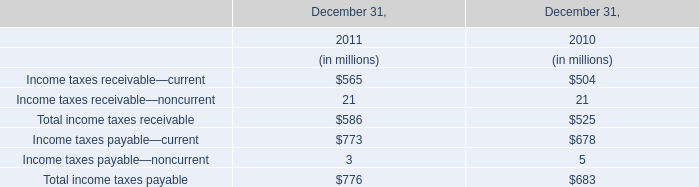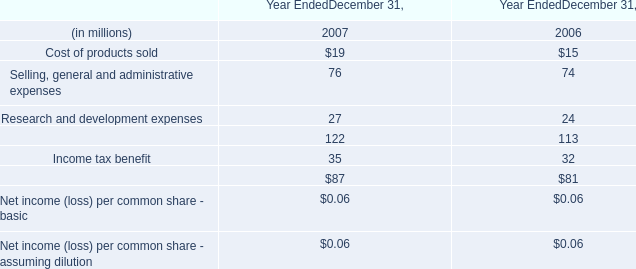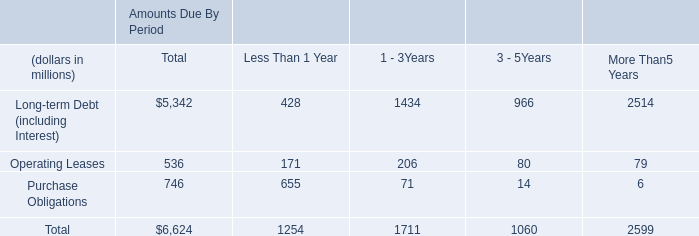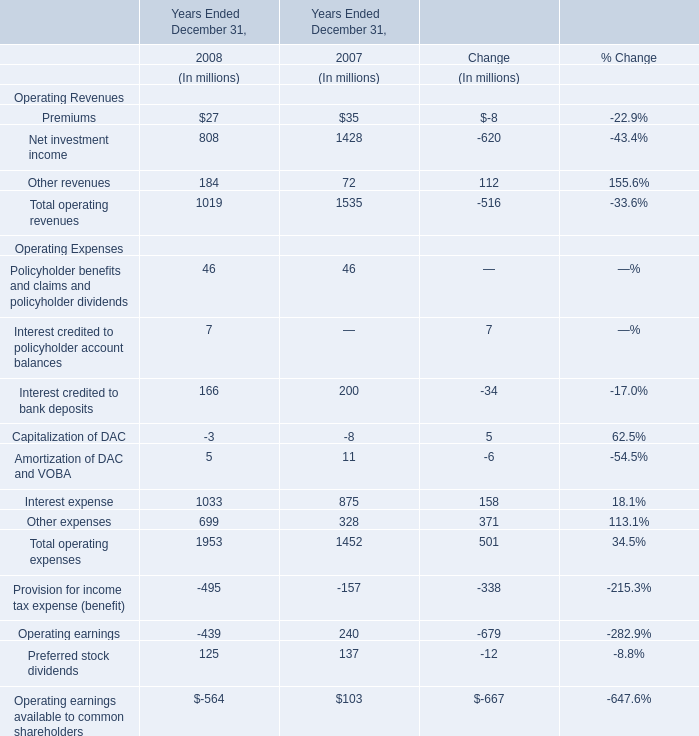What is the value of the Total operating revenues in the Year where Operating earnings is positive? (in million) 
Answer: 1535. 